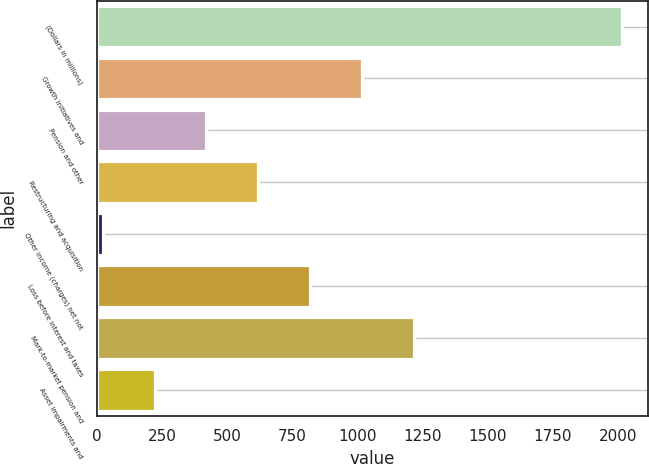Convert chart to OTSL. <chart><loc_0><loc_0><loc_500><loc_500><bar_chart><fcel>(Dollars in millions)<fcel>Growth initiatives and<fcel>Pension and other<fcel>Restructuring and acquisition<fcel>Other income (charges) net not<fcel>Loss before interest and taxes<fcel>Mark-to-market pension and<fcel>Asset impairments and<nl><fcel>2016<fcel>1019<fcel>420.8<fcel>620.2<fcel>22<fcel>819.6<fcel>1218.4<fcel>221.4<nl></chart> 